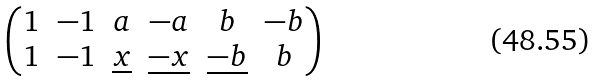<formula> <loc_0><loc_0><loc_500><loc_500>\begin{pmatrix} 1 & - 1 & a & - a & b & - b \\ 1 & - 1 & \underline { x } & \underline { - x } & \underline { - b } & b \end{pmatrix}</formula> 